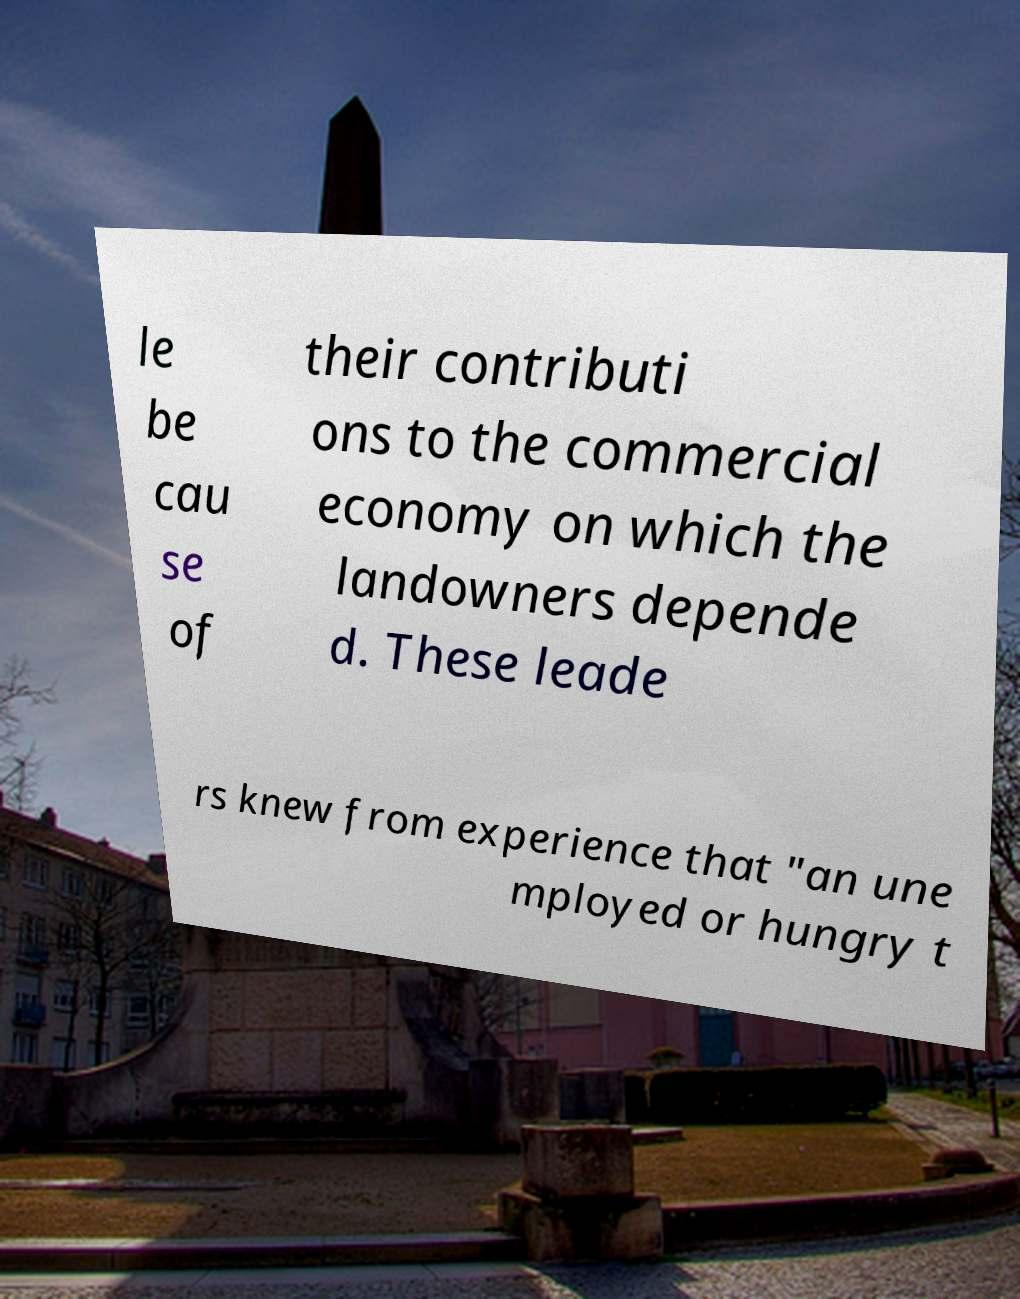For documentation purposes, I need the text within this image transcribed. Could you provide that? le be cau se of their contributi ons to the commercial economy on which the landowners depende d. These leade rs knew from experience that "an une mployed or hungry t 